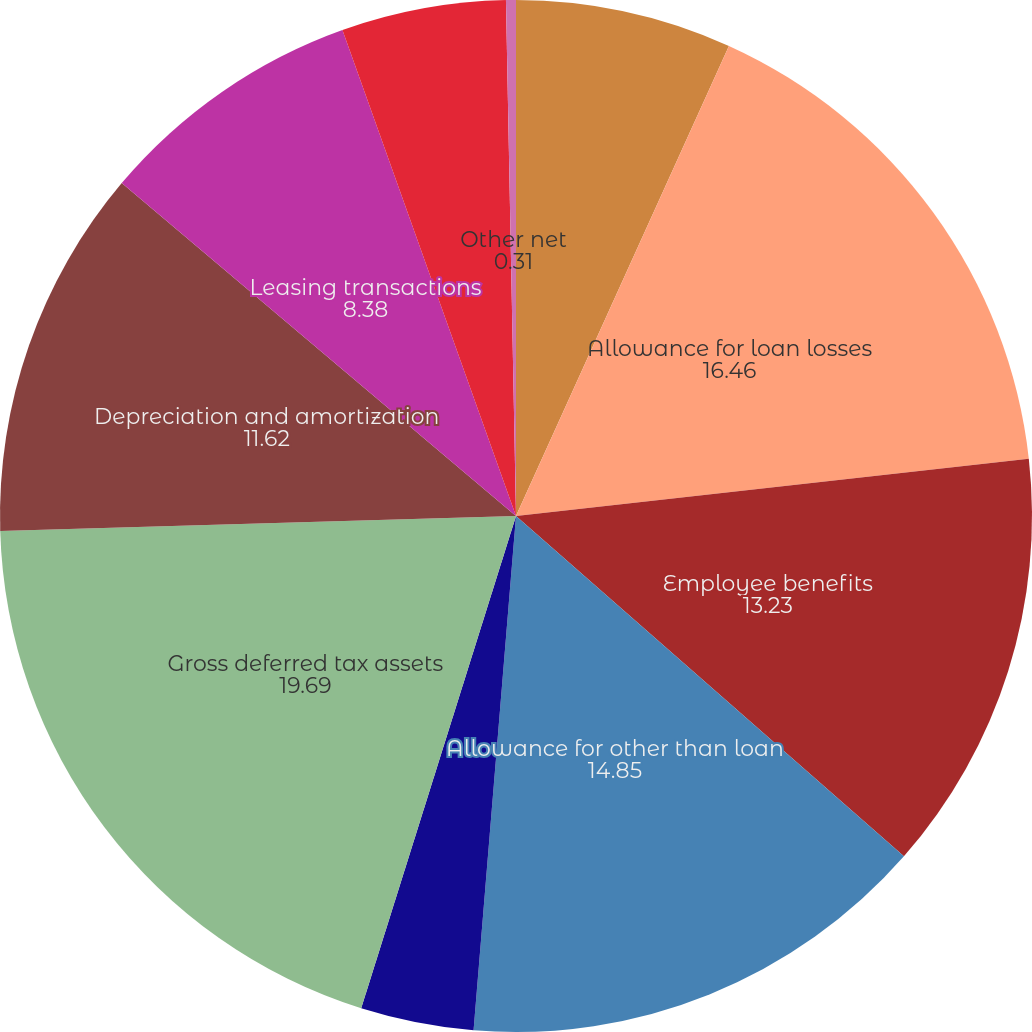Convert chart. <chart><loc_0><loc_0><loc_500><loc_500><pie_chart><fcel>December 31 (in millions)<fcel>Allowance for loan losses<fcel>Employee benefits<fcel>Allowance for other than loan<fcel>Non-US operations<fcel>Gross deferred tax assets<fcel>Depreciation and amortization<fcel>Leasing transactions<fcel>Fee income<fcel>Other net<nl><fcel>6.77%<fcel>16.46%<fcel>13.23%<fcel>14.85%<fcel>3.54%<fcel>19.69%<fcel>11.62%<fcel>8.38%<fcel>5.15%<fcel>0.31%<nl></chart> 